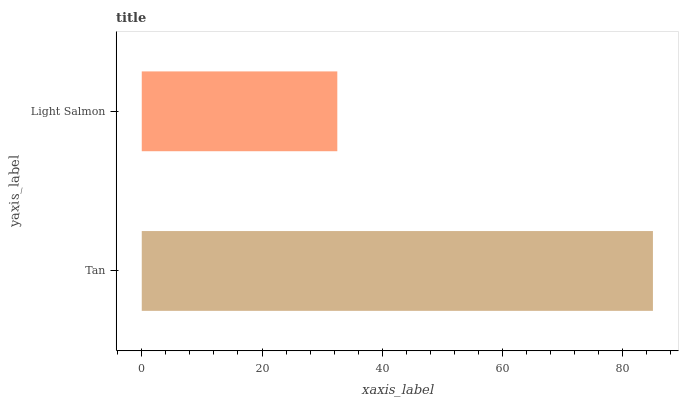Is Light Salmon the minimum?
Answer yes or no. Yes. Is Tan the maximum?
Answer yes or no. Yes. Is Light Salmon the maximum?
Answer yes or no. No. Is Tan greater than Light Salmon?
Answer yes or no. Yes. Is Light Salmon less than Tan?
Answer yes or no. Yes. Is Light Salmon greater than Tan?
Answer yes or no. No. Is Tan less than Light Salmon?
Answer yes or no. No. Is Tan the high median?
Answer yes or no. Yes. Is Light Salmon the low median?
Answer yes or no. Yes. Is Light Salmon the high median?
Answer yes or no. No. Is Tan the low median?
Answer yes or no. No. 